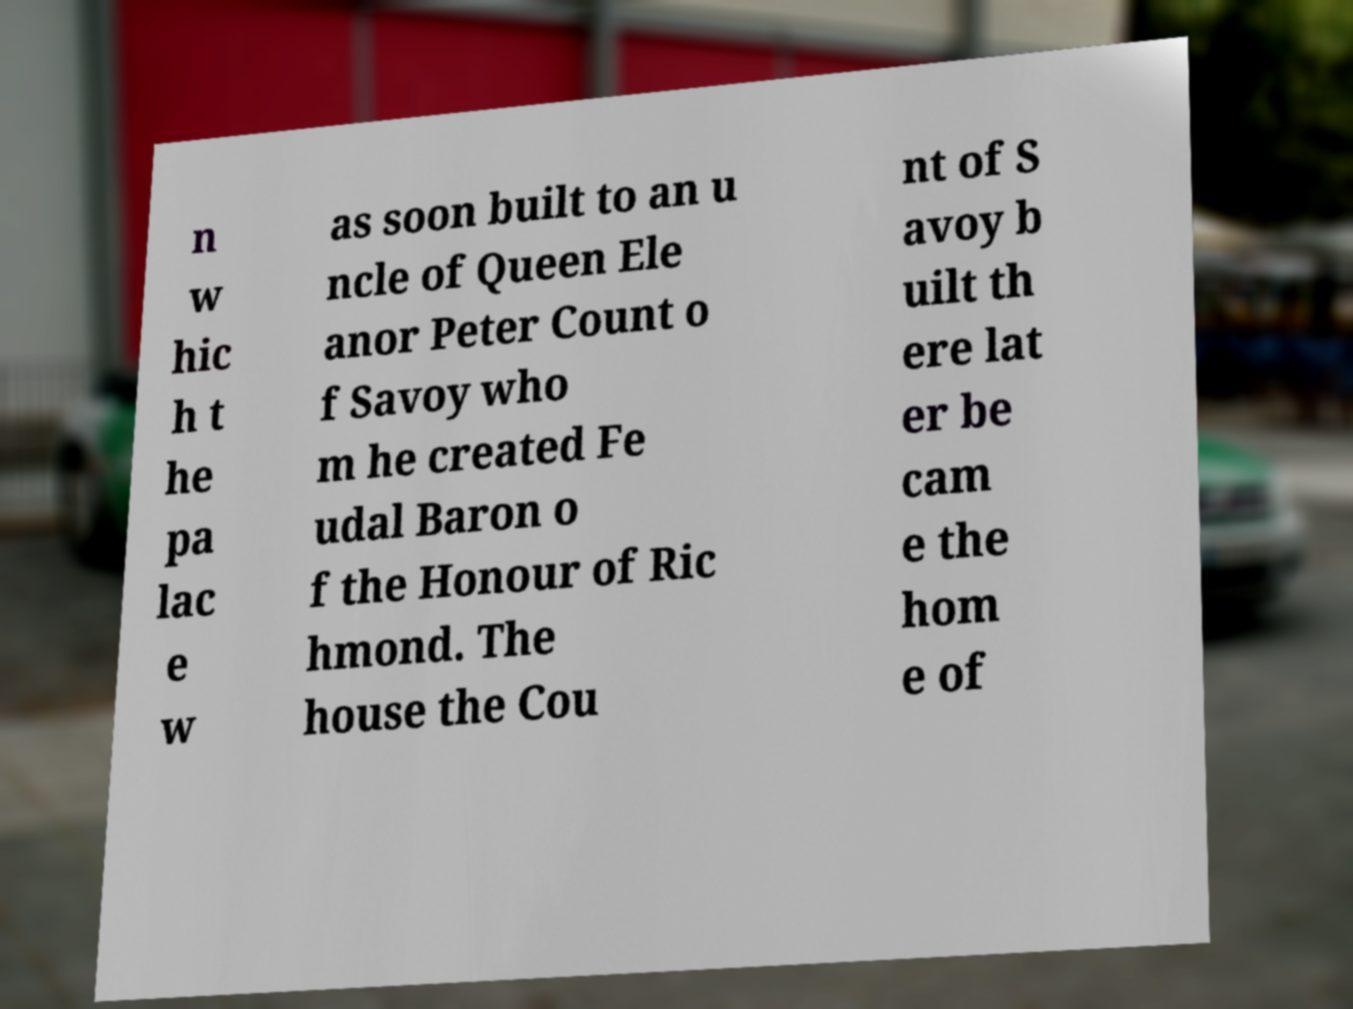There's text embedded in this image that I need extracted. Can you transcribe it verbatim? n w hic h t he pa lac e w as soon built to an u ncle of Queen Ele anor Peter Count o f Savoy who m he created Fe udal Baron o f the Honour of Ric hmond. The house the Cou nt of S avoy b uilt th ere lat er be cam e the hom e of 